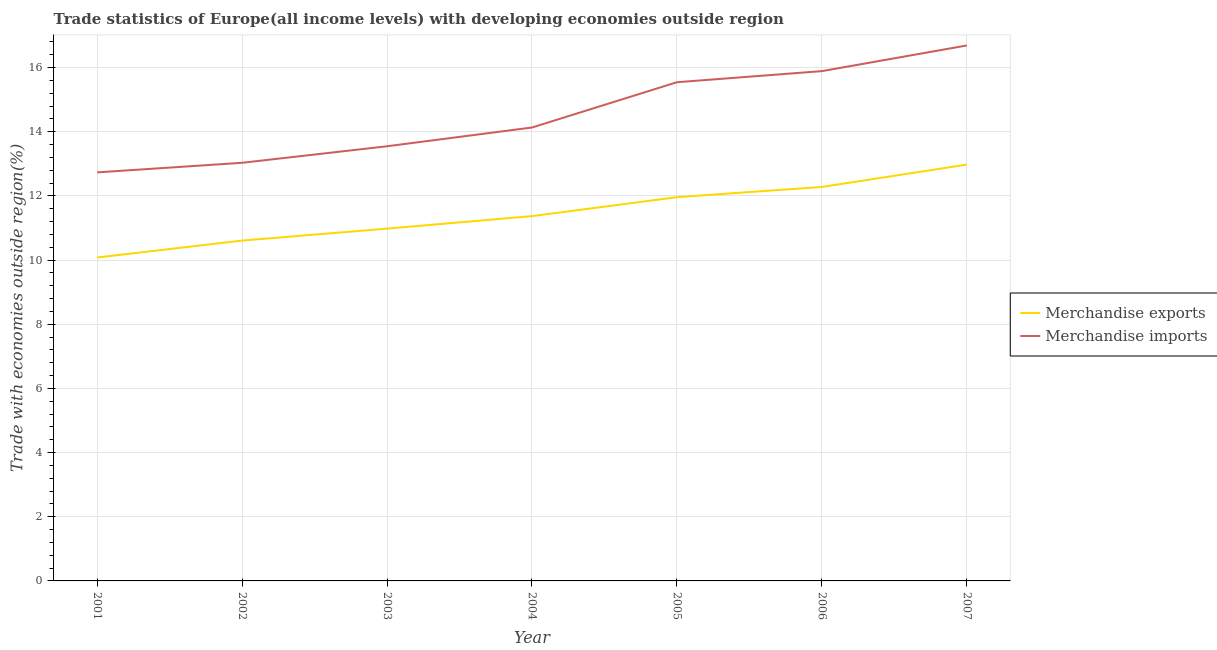How many different coloured lines are there?
Give a very brief answer. 2. Is the number of lines equal to the number of legend labels?
Offer a very short reply. Yes. What is the merchandise imports in 2002?
Your answer should be compact. 13.03. Across all years, what is the maximum merchandise imports?
Provide a short and direct response. 16.69. Across all years, what is the minimum merchandise imports?
Give a very brief answer. 12.73. In which year was the merchandise exports maximum?
Your answer should be very brief. 2007. In which year was the merchandise exports minimum?
Your response must be concise. 2001. What is the total merchandise exports in the graph?
Offer a terse response. 80.25. What is the difference between the merchandise imports in 2002 and that in 2007?
Offer a terse response. -3.66. What is the difference between the merchandise imports in 2002 and the merchandise exports in 2006?
Provide a succinct answer. 0.75. What is the average merchandise imports per year?
Provide a short and direct response. 14.51. In the year 2004, what is the difference between the merchandise exports and merchandise imports?
Make the answer very short. -2.76. What is the ratio of the merchandise exports in 2002 to that in 2005?
Give a very brief answer. 0.89. Is the merchandise imports in 2003 less than that in 2007?
Give a very brief answer. Yes. Is the difference between the merchandise imports in 2001 and 2003 greater than the difference between the merchandise exports in 2001 and 2003?
Your answer should be very brief. Yes. What is the difference between the highest and the second highest merchandise imports?
Ensure brevity in your answer.  0.8. What is the difference between the highest and the lowest merchandise imports?
Offer a very short reply. 3.95. In how many years, is the merchandise exports greater than the average merchandise exports taken over all years?
Make the answer very short. 3. Is the sum of the merchandise imports in 2002 and 2003 greater than the maximum merchandise exports across all years?
Keep it short and to the point. Yes. Does the merchandise imports monotonically increase over the years?
Give a very brief answer. Yes. How many lines are there?
Give a very brief answer. 2. How many years are there in the graph?
Keep it short and to the point. 7. What is the difference between two consecutive major ticks on the Y-axis?
Give a very brief answer. 2. Where does the legend appear in the graph?
Give a very brief answer. Center right. What is the title of the graph?
Give a very brief answer. Trade statistics of Europe(all income levels) with developing economies outside region. Does "Primary education" appear as one of the legend labels in the graph?
Your response must be concise. No. What is the label or title of the X-axis?
Offer a very short reply. Year. What is the label or title of the Y-axis?
Offer a very short reply. Trade with economies outside region(%). What is the Trade with economies outside region(%) in Merchandise exports in 2001?
Provide a short and direct response. 10.08. What is the Trade with economies outside region(%) of Merchandise imports in 2001?
Ensure brevity in your answer.  12.73. What is the Trade with economies outside region(%) of Merchandise exports in 2002?
Your response must be concise. 10.61. What is the Trade with economies outside region(%) in Merchandise imports in 2002?
Give a very brief answer. 13.03. What is the Trade with economies outside region(%) of Merchandise exports in 2003?
Your response must be concise. 10.98. What is the Trade with economies outside region(%) in Merchandise imports in 2003?
Keep it short and to the point. 13.55. What is the Trade with economies outside region(%) in Merchandise exports in 2004?
Offer a terse response. 11.37. What is the Trade with economies outside region(%) of Merchandise imports in 2004?
Offer a terse response. 14.13. What is the Trade with economies outside region(%) of Merchandise exports in 2005?
Your answer should be compact. 11.96. What is the Trade with economies outside region(%) in Merchandise imports in 2005?
Ensure brevity in your answer.  15.54. What is the Trade with economies outside region(%) in Merchandise exports in 2006?
Your response must be concise. 12.28. What is the Trade with economies outside region(%) in Merchandise imports in 2006?
Your response must be concise. 15.89. What is the Trade with economies outside region(%) of Merchandise exports in 2007?
Make the answer very short. 12.98. What is the Trade with economies outside region(%) of Merchandise imports in 2007?
Offer a very short reply. 16.69. Across all years, what is the maximum Trade with economies outside region(%) in Merchandise exports?
Provide a short and direct response. 12.98. Across all years, what is the maximum Trade with economies outside region(%) of Merchandise imports?
Keep it short and to the point. 16.69. Across all years, what is the minimum Trade with economies outside region(%) in Merchandise exports?
Your answer should be compact. 10.08. Across all years, what is the minimum Trade with economies outside region(%) of Merchandise imports?
Give a very brief answer. 12.73. What is the total Trade with economies outside region(%) in Merchandise exports in the graph?
Your response must be concise. 80.25. What is the total Trade with economies outside region(%) in Merchandise imports in the graph?
Your answer should be compact. 101.56. What is the difference between the Trade with economies outside region(%) in Merchandise exports in 2001 and that in 2002?
Provide a short and direct response. -0.53. What is the difference between the Trade with economies outside region(%) of Merchandise imports in 2001 and that in 2002?
Provide a short and direct response. -0.3. What is the difference between the Trade with economies outside region(%) of Merchandise exports in 2001 and that in 2003?
Give a very brief answer. -0.9. What is the difference between the Trade with economies outside region(%) in Merchandise imports in 2001 and that in 2003?
Provide a short and direct response. -0.81. What is the difference between the Trade with economies outside region(%) of Merchandise exports in 2001 and that in 2004?
Keep it short and to the point. -1.29. What is the difference between the Trade with economies outside region(%) of Merchandise imports in 2001 and that in 2004?
Provide a succinct answer. -1.4. What is the difference between the Trade with economies outside region(%) of Merchandise exports in 2001 and that in 2005?
Keep it short and to the point. -1.88. What is the difference between the Trade with economies outside region(%) in Merchandise imports in 2001 and that in 2005?
Your answer should be compact. -2.81. What is the difference between the Trade with economies outside region(%) in Merchandise exports in 2001 and that in 2006?
Give a very brief answer. -2.2. What is the difference between the Trade with economies outside region(%) in Merchandise imports in 2001 and that in 2006?
Provide a succinct answer. -3.16. What is the difference between the Trade with economies outside region(%) of Merchandise exports in 2001 and that in 2007?
Provide a short and direct response. -2.9. What is the difference between the Trade with economies outside region(%) of Merchandise imports in 2001 and that in 2007?
Your answer should be very brief. -3.95. What is the difference between the Trade with economies outside region(%) in Merchandise exports in 2002 and that in 2003?
Give a very brief answer. -0.37. What is the difference between the Trade with economies outside region(%) in Merchandise imports in 2002 and that in 2003?
Your answer should be very brief. -0.52. What is the difference between the Trade with economies outside region(%) in Merchandise exports in 2002 and that in 2004?
Your response must be concise. -0.76. What is the difference between the Trade with economies outside region(%) in Merchandise imports in 2002 and that in 2004?
Provide a succinct answer. -1.1. What is the difference between the Trade with economies outside region(%) in Merchandise exports in 2002 and that in 2005?
Keep it short and to the point. -1.35. What is the difference between the Trade with economies outside region(%) of Merchandise imports in 2002 and that in 2005?
Your answer should be compact. -2.51. What is the difference between the Trade with economies outside region(%) in Merchandise exports in 2002 and that in 2006?
Provide a succinct answer. -1.67. What is the difference between the Trade with economies outside region(%) of Merchandise imports in 2002 and that in 2006?
Provide a succinct answer. -2.86. What is the difference between the Trade with economies outside region(%) in Merchandise exports in 2002 and that in 2007?
Give a very brief answer. -2.37. What is the difference between the Trade with economies outside region(%) of Merchandise imports in 2002 and that in 2007?
Keep it short and to the point. -3.66. What is the difference between the Trade with economies outside region(%) in Merchandise exports in 2003 and that in 2004?
Your response must be concise. -0.39. What is the difference between the Trade with economies outside region(%) in Merchandise imports in 2003 and that in 2004?
Make the answer very short. -0.58. What is the difference between the Trade with economies outside region(%) in Merchandise exports in 2003 and that in 2005?
Keep it short and to the point. -0.98. What is the difference between the Trade with economies outside region(%) in Merchandise imports in 2003 and that in 2005?
Provide a short and direct response. -2. What is the difference between the Trade with economies outside region(%) in Merchandise exports in 2003 and that in 2006?
Offer a terse response. -1.3. What is the difference between the Trade with economies outside region(%) in Merchandise imports in 2003 and that in 2006?
Give a very brief answer. -2.34. What is the difference between the Trade with economies outside region(%) in Merchandise exports in 2003 and that in 2007?
Your answer should be compact. -2. What is the difference between the Trade with economies outside region(%) of Merchandise imports in 2003 and that in 2007?
Keep it short and to the point. -3.14. What is the difference between the Trade with economies outside region(%) in Merchandise exports in 2004 and that in 2005?
Make the answer very short. -0.59. What is the difference between the Trade with economies outside region(%) in Merchandise imports in 2004 and that in 2005?
Your answer should be very brief. -1.41. What is the difference between the Trade with economies outside region(%) in Merchandise exports in 2004 and that in 2006?
Provide a short and direct response. -0.91. What is the difference between the Trade with economies outside region(%) of Merchandise imports in 2004 and that in 2006?
Your answer should be compact. -1.76. What is the difference between the Trade with economies outside region(%) of Merchandise exports in 2004 and that in 2007?
Provide a succinct answer. -1.61. What is the difference between the Trade with economies outside region(%) in Merchandise imports in 2004 and that in 2007?
Provide a succinct answer. -2.56. What is the difference between the Trade with economies outside region(%) in Merchandise exports in 2005 and that in 2006?
Provide a succinct answer. -0.32. What is the difference between the Trade with economies outside region(%) in Merchandise imports in 2005 and that in 2006?
Your answer should be very brief. -0.35. What is the difference between the Trade with economies outside region(%) of Merchandise exports in 2005 and that in 2007?
Offer a very short reply. -1.02. What is the difference between the Trade with economies outside region(%) in Merchandise imports in 2005 and that in 2007?
Provide a succinct answer. -1.15. What is the difference between the Trade with economies outside region(%) in Merchandise exports in 2006 and that in 2007?
Your response must be concise. -0.7. What is the difference between the Trade with economies outside region(%) in Merchandise imports in 2006 and that in 2007?
Your answer should be compact. -0.8. What is the difference between the Trade with economies outside region(%) of Merchandise exports in 2001 and the Trade with economies outside region(%) of Merchandise imports in 2002?
Offer a very short reply. -2.95. What is the difference between the Trade with economies outside region(%) in Merchandise exports in 2001 and the Trade with economies outside region(%) in Merchandise imports in 2003?
Offer a very short reply. -3.47. What is the difference between the Trade with economies outside region(%) of Merchandise exports in 2001 and the Trade with economies outside region(%) of Merchandise imports in 2004?
Your answer should be compact. -4.05. What is the difference between the Trade with economies outside region(%) of Merchandise exports in 2001 and the Trade with economies outside region(%) of Merchandise imports in 2005?
Your answer should be very brief. -5.46. What is the difference between the Trade with economies outside region(%) in Merchandise exports in 2001 and the Trade with economies outside region(%) in Merchandise imports in 2006?
Make the answer very short. -5.81. What is the difference between the Trade with economies outside region(%) of Merchandise exports in 2001 and the Trade with economies outside region(%) of Merchandise imports in 2007?
Your answer should be very brief. -6.61. What is the difference between the Trade with economies outside region(%) of Merchandise exports in 2002 and the Trade with economies outside region(%) of Merchandise imports in 2003?
Your answer should be very brief. -2.94. What is the difference between the Trade with economies outside region(%) of Merchandise exports in 2002 and the Trade with economies outside region(%) of Merchandise imports in 2004?
Your answer should be very brief. -3.52. What is the difference between the Trade with economies outside region(%) in Merchandise exports in 2002 and the Trade with economies outside region(%) in Merchandise imports in 2005?
Offer a very short reply. -4.93. What is the difference between the Trade with economies outside region(%) of Merchandise exports in 2002 and the Trade with economies outside region(%) of Merchandise imports in 2006?
Keep it short and to the point. -5.28. What is the difference between the Trade with economies outside region(%) in Merchandise exports in 2002 and the Trade with economies outside region(%) in Merchandise imports in 2007?
Give a very brief answer. -6.08. What is the difference between the Trade with economies outside region(%) in Merchandise exports in 2003 and the Trade with economies outside region(%) in Merchandise imports in 2004?
Make the answer very short. -3.15. What is the difference between the Trade with economies outside region(%) in Merchandise exports in 2003 and the Trade with economies outside region(%) in Merchandise imports in 2005?
Provide a succinct answer. -4.56. What is the difference between the Trade with economies outside region(%) in Merchandise exports in 2003 and the Trade with economies outside region(%) in Merchandise imports in 2006?
Ensure brevity in your answer.  -4.91. What is the difference between the Trade with economies outside region(%) in Merchandise exports in 2003 and the Trade with economies outside region(%) in Merchandise imports in 2007?
Provide a short and direct response. -5.71. What is the difference between the Trade with economies outside region(%) of Merchandise exports in 2004 and the Trade with economies outside region(%) of Merchandise imports in 2005?
Provide a succinct answer. -4.17. What is the difference between the Trade with economies outside region(%) in Merchandise exports in 2004 and the Trade with economies outside region(%) in Merchandise imports in 2006?
Make the answer very short. -4.52. What is the difference between the Trade with economies outside region(%) of Merchandise exports in 2004 and the Trade with economies outside region(%) of Merchandise imports in 2007?
Offer a very short reply. -5.32. What is the difference between the Trade with economies outside region(%) of Merchandise exports in 2005 and the Trade with economies outside region(%) of Merchandise imports in 2006?
Make the answer very short. -3.93. What is the difference between the Trade with economies outside region(%) of Merchandise exports in 2005 and the Trade with economies outside region(%) of Merchandise imports in 2007?
Your answer should be very brief. -4.73. What is the difference between the Trade with economies outside region(%) in Merchandise exports in 2006 and the Trade with economies outside region(%) in Merchandise imports in 2007?
Your answer should be very brief. -4.41. What is the average Trade with economies outside region(%) of Merchandise exports per year?
Give a very brief answer. 11.46. What is the average Trade with economies outside region(%) of Merchandise imports per year?
Your answer should be very brief. 14.51. In the year 2001, what is the difference between the Trade with economies outside region(%) of Merchandise exports and Trade with economies outside region(%) of Merchandise imports?
Give a very brief answer. -2.65. In the year 2002, what is the difference between the Trade with economies outside region(%) of Merchandise exports and Trade with economies outside region(%) of Merchandise imports?
Make the answer very short. -2.42. In the year 2003, what is the difference between the Trade with economies outside region(%) of Merchandise exports and Trade with economies outside region(%) of Merchandise imports?
Offer a terse response. -2.57. In the year 2004, what is the difference between the Trade with economies outside region(%) of Merchandise exports and Trade with economies outside region(%) of Merchandise imports?
Ensure brevity in your answer.  -2.76. In the year 2005, what is the difference between the Trade with economies outside region(%) of Merchandise exports and Trade with economies outside region(%) of Merchandise imports?
Ensure brevity in your answer.  -3.58. In the year 2006, what is the difference between the Trade with economies outside region(%) of Merchandise exports and Trade with economies outside region(%) of Merchandise imports?
Give a very brief answer. -3.61. In the year 2007, what is the difference between the Trade with economies outside region(%) of Merchandise exports and Trade with economies outside region(%) of Merchandise imports?
Provide a succinct answer. -3.71. What is the ratio of the Trade with economies outside region(%) in Merchandise exports in 2001 to that in 2002?
Provide a short and direct response. 0.95. What is the ratio of the Trade with economies outside region(%) of Merchandise imports in 2001 to that in 2002?
Make the answer very short. 0.98. What is the ratio of the Trade with economies outside region(%) in Merchandise exports in 2001 to that in 2003?
Give a very brief answer. 0.92. What is the ratio of the Trade with economies outside region(%) in Merchandise imports in 2001 to that in 2003?
Give a very brief answer. 0.94. What is the ratio of the Trade with economies outside region(%) of Merchandise exports in 2001 to that in 2004?
Offer a very short reply. 0.89. What is the ratio of the Trade with economies outside region(%) of Merchandise imports in 2001 to that in 2004?
Keep it short and to the point. 0.9. What is the ratio of the Trade with economies outside region(%) in Merchandise exports in 2001 to that in 2005?
Offer a terse response. 0.84. What is the ratio of the Trade with economies outside region(%) of Merchandise imports in 2001 to that in 2005?
Provide a short and direct response. 0.82. What is the ratio of the Trade with economies outside region(%) in Merchandise exports in 2001 to that in 2006?
Your response must be concise. 0.82. What is the ratio of the Trade with economies outside region(%) of Merchandise imports in 2001 to that in 2006?
Offer a very short reply. 0.8. What is the ratio of the Trade with economies outside region(%) in Merchandise exports in 2001 to that in 2007?
Give a very brief answer. 0.78. What is the ratio of the Trade with economies outside region(%) of Merchandise imports in 2001 to that in 2007?
Give a very brief answer. 0.76. What is the ratio of the Trade with economies outside region(%) in Merchandise exports in 2002 to that in 2003?
Make the answer very short. 0.97. What is the ratio of the Trade with economies outside region(%) of Merchandise imports in 2002 to that in 2003?
Your answer should be very brief. 0.96. What is the ratio of the Trade with economies outside region(%) of Merchandise exports in 2002 to that in 2004?
Offer a very short reply. 0.93. What is the ratio of the Trade with economies outside region(%) in Merchandise imports in 2002 to that in 2004?
Provide a succinct answer. 0.92. What is the ratio of the Trade with economies outside region(%) of Merchandise exports in 2002 to that in 2005?
Offer a terse response. 0.89. What is the ratio of the Trade with economies outside region(%) in Merchandise imports in 2002 to that in 2005?
Offer a very short reply. 0.84. What is the ratio of the Trade with economies outside region(%) of Merchandise exports in 2002 to that in 2006?
Your response must be concise. 0.86. What is the ratio of the Trade with economies outside region(%) of Merchandise imports in 2002 to that in 2006?
Offer a terse response. 0.82. What is the ratio of the Trade with economies outside region(%) of Merchandise exports in 2002 to that in 2007?
Provide a short and direct response. 0.82. What is the ratio of the Trade with economies outside region(%) in Merchandise imports in 2002 to that in 2007?
Offer a very short reply. 0.78. What is the ratio of the Trade with economies outside region(%) in Merchandise exports in 2003 to that in 2004?
Keep it short and to the point. 0.97. What is the ratio of the Trade with economies outside region(%) in Merchandise imports in 2003 to that in 2004?
Make the answer very short. 0.96. What is the ratio of the Trade with economies outside region(%) in Merchandise exports in 2003 to that in 2005?
Offer a terse response. 0.92. What is the ratio of the Trade with economies outside region(%) of Merchandise imports in 2003 to that in 2005?
Give a very brief answer. 0.87. What is the ratio of the Trade with economies outside region(%) in Merchandise exports in 2003 to that in 2006?
Provide a succinct answer. 0.89. What is the ratio of the Trade with economies outside region(%) in Merchandise imports in 2003 to that in 2006?
Ensure brevity in your answer.  0.85. What is the ratio of the Trade with economies outside region(%) in Merchandise exports in 2003 to that in 2007?
Provide a succinct answer. 0.85. What is the ratio of the Trade with economies outside region(%) of Merchandise imports in 2003 to that in 2007?
Your response must be concise. 0.81. What is the ratio of the Trade with economies outside region(%) in Merchandise exports in 2004 to that in 2005?
Your answer should be compact. 0.95. What is the ratio of the Trade with economies outside region(%) of Merchandise imports in 2004 to that in 2005?
Ensure brevity in your answer.  0.91. What is the ratio of the Trade with economies outside region(%) of Merchandise exports in 2004 to that in 2006?
Your response must be concise. 0.93. What is the ratio of the Trade with economies outside region(%) in Merchandise imports in 2004 to that in 2006?
Provide a succinct answer. 0.89. What is the ratio of the Trade with economies outside region(%) in Merchandise exports in 2004 to that in 2007?
Your response must be concise. 0.88. What is the ratio of the Trade with economies outside region(%) in Merchandise imports in 2004 to that in 2007?
Make the answer very short. 0.85. What is the ratio of the Trade with economies outside region(%) in Merchandise imports in 2005 to that in 2006?
Offer a very short reply. 0.98. What is the ratio of the Trade with economies outside region(%) of Merchandise exports in 2005 to that in 2007?
Provide a short and direct response. 0.92. What is the ratio of the Trade with economies outside region(%) in Merchandise imports in 2005 to that in 2007?
Provide a short and direct response. 0.93. What is the ratio of the Trade with economies outside region(%) of Merchandise exports in 2006 to that in 2007?
Offer a terse response. 0.95. What is the ratio of the Trade with economies outside region(%) of Merchandise imports in 2006 to that in 2007?
Your answer should be compact. 0.95. What is the difference between the highest and the second highest Trade with economies outside region(%) of Merchandise exports?
Your answer should be very brief. 0.7. What is the difference between the highest and the second highest Trade with economies outside region(%) of Merchandise imports?
Offer a terse response. 0.8. What is the difference between the highest and the lowest Trade with economies outside region(%) of Merchandise exports?
Ensure brevity in your answer.  2.9. What is the difference between the highest and the lowest Trade with economies outside region(%) of Merchandise imports?
Your response must be concise. 3.95. 